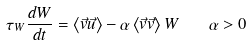<formula> <loc_0><loc_0><loc_500><loc_500>\tau _ { W } \frac { d W } { d t } = \left \langle \vec { v } \vec { u } \right \rangle - \alpha \left \langle \vec { v } \vec { v } \right \rangle W \quad \alpha > 0</formula> 